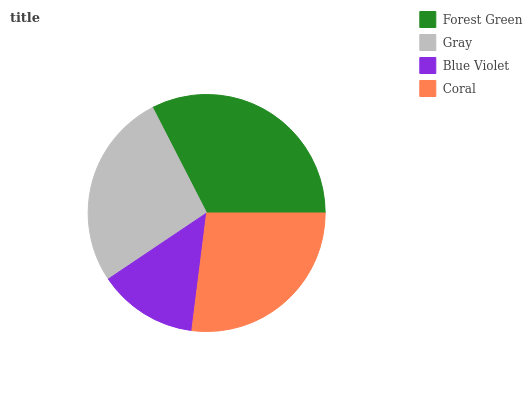Is Blue Violet the minimum?
Answer yes or no. Yes. Is Forest Green the maximum?
Answer yes or no. Yes. Is Gray the minimum?
Answer yes or no. No. Is Gray the maximum?
Answer yes or no. No. Is Forest Green greater than Gray?
Answer yes or no. Yes. Is Gray less than Forest Green?
Answer yes or no. Yes. Is Gray greater than Forest Green?
Answer yes or no. No. Is Forest Green less than Gray?
Answer yes or no. No. Is Coral the high median?
Answer yes or no. Yes. Is Gray the low median?
Answer yes or no. Yes. Is Forest Green the high median?
Answer yes or no. No. Is Blue Violet the low median?
Answer yes or no. No. 